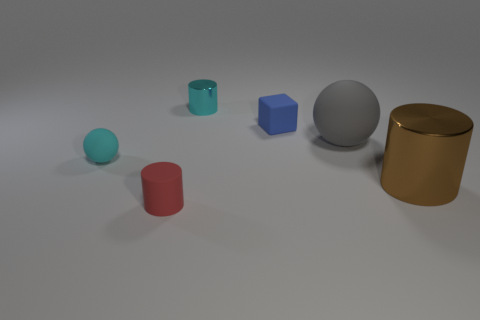Is there anything else that is the same material as the small red cylinder?
Offer a terse response. Yes. The ball behind the cyan object in front of the small cyan thing that is behind the cyan matte ball is what color?
Give a very brief answer. Gray. Are the blue thing and the big brown object made of the same material?
Give a very brief answer. No. Are there any metallic cylinders of the same size as the gray rubber sphere?
Your answer should be very brief. Yes. There is a cyan ball that is the same size as the matte cube; what is it made of?
Provide a short and direct response. Rubber. Is there another large brown object that has the same shape as the big matte thing?
Your response must be concise. No. There is another tiny thing that is the same color as the tiny metal thing; what is its material?
Make the answer very short. Rubber. What is the shape of the small cyan object that is to the left of the small red matte object?
Your answer should be compact. Sphere. How many big shiny objects are there?
Give a very brief answer. 1. There is a cylinder that is made of the same material as the brown thing; what is its color?
Provide a short and direct response. Cyan. 